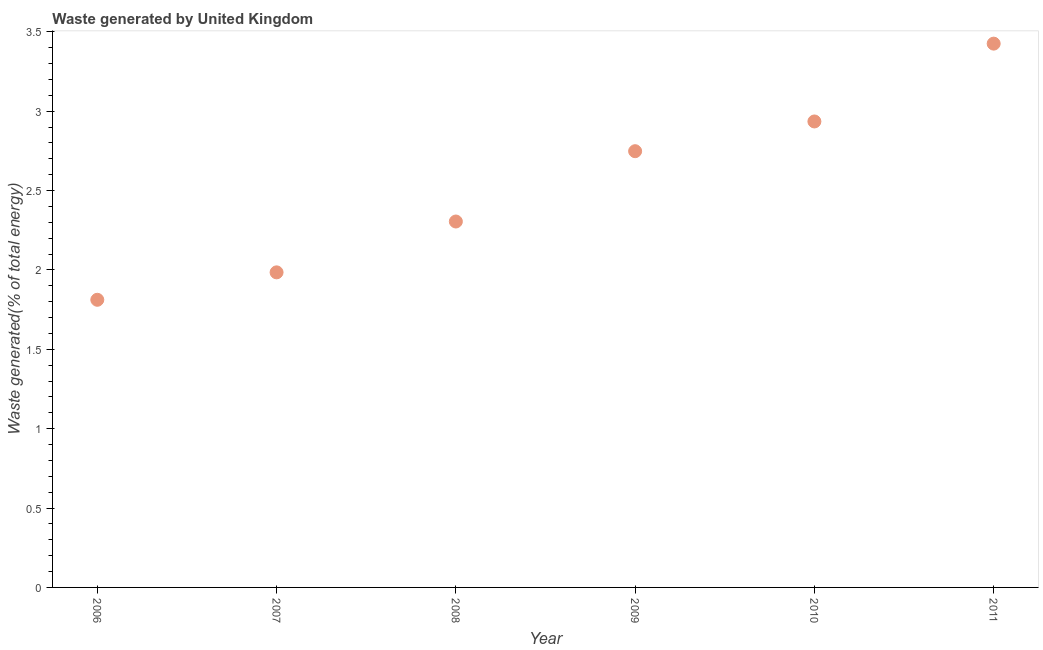What is the amount of waste generated in 2009?
Provide a short and direct response. 2.75. Across all years, what is the maximum amount of waste generated?
Offer a terse response. 3.43. Across all years, what is the minimum amount of waste generated?
Your answer should be very brief. 1.81. In which year was the amount of waste generated maximum?
Ensure brevity in your answer.  2011. What is the sum of the amount of waste generated?
Your response must be concise. 15.21. What is the difference between the amount of waste generated in 2010 and 2011?
Make the answer very short. -0.49. What is the average amount of waste generated per year?
Provide a succinct answer. 2.53. What is the median amount of waste generated?
Make the answer very short. 2.53. What is the ratio of the amount of waste generated in 2007 to that in 2008?
Make the answer very short. 0.86. What is the difference between the highest and the second highest amount of waste generated?
Provide a succinct answer. 0.49. Is the sum of the amount of waste generated in 2007 and 2011 greater than the maximum amount of waste generated across all years?
Provide a succinct answer. Yes. What is the difference between the highest and the lowest amount of waste generated?
Provide a succinct answer. 1.61. Does the amount of waste generated monotonically increase over the years?
Make the answer very short. Yes. How many dotlines are there?
Your response must be concise. 1. Are the values on the major ticks of Y-axis written in scientific E-notation?
Offer a terse response. No. Does the graph contain any zero values?
Your answer should be compact. No. Does the graph contain grids?
Provide a short and direct response. No. What is the title of the graph?
Make the answer very short. Waste generated by United Kingdom. What is the label or title of the X-axis?
Provide a succinct answer. Year. What is the label or title of the Y-axis?
Offer a very short reply. Waste generated(% of total energy). What is the Waste generated(% of total energy) in 2006?
Provide a short and direct response. 1.81. What is the Waste generated(% of total energy) in 2007?
Provide a succinct answer. 1.98. What is the Waste generated(% of total energy) in 2008?
Give a very brief answer. 2.3. What is the Waste generated(% of total energy) in 2009?
Give a very brief answer. 2.75. What is the Waste generated(% of total energy) in 2010?
Your response must be concise. 2.94. What is the Waste generated(% of total energy) in 2011?
Keep it short and to the point. 3.43. What is the difference between the Waste generated(% of total energy) in 2006 and 2007?
Your answer should be compact. -0.17. What is the difference between the Waste generated(% of total energy) in 2006 and 2008?
Your response must be concise. -0.49. What is the difference between the Waste generated(% of total energy) in 2006 and 2009?
Ensure brevity in your answer.  -0.94. What is the difference between the Waste generated(% of total energy) in 2006 and 2010?
Give a very brief answer. -1.12. What is the difference between the Waste generated(% of total energy) in 2006 and 2011?
Make the answer very short. -1.61. What is the difference between the Waste generated(% of total energy) in 2007 and 2008?
Offer a very short reply. -0.32. What is the difference between the Waste generated(% of total energy) in 2007 and 2009?
Your answer should be very brief. -0.76. What is the difference between the Waste generated(% of total energy) in 2007 and 2010?
Your answer should be compact. -0.95. What is the difference between the Waste generated(% of total energy) in 2007 and 2011?
Keep it short and to the point. -1.44. What is the difference between the Waste generated(% of total energy) in 2008 and 2009?
Keep it short and to the point. -0.44. What is the difference between the Waste generated(% of total energy) in 2008 and 2010?
Your answer should be very brief. -0.63. What is the difference between the Waste generated(% of total energy) in 2008 and 2011?
Your response must be concise. -1.12. What is the difference between the Waste generated(% of total energy) in 2009 and 2010?
Make the answer very short. -0.19. What is the difference between the Waste generated(% of total energy) in 2009 and 2011?
Offer a terse response. -0.68. What is the difference between the Waste generated(% of total energy) in 2010 and 2011?
Keep it short and to the point. -0.49. What is the ratio of the Waste generated(% of total energy) in 2006 to that in 2007?
Make the answer very short. 0.91. What is the ratio of the Waste generated(% of total energy) in 2006 to that in 2008?
Ensure brevity in your answer.  0.79. What is the ratio of the Waste generated(% of total energy) in 2006 to that in 2009?
Keep it short and to the point. 0.66. What is the ratio of the Waste generated(% of total energy) in 2006 to that in 2010?
Keep it short and to the point. 0.62. What is the ratio of the Waste generated(% of total energy) in 2006 to that in 2011?
Provide a short and direct response. 0.53. What is the ratio of the Waste generated(% of total energy) in 2007 to that in 2008?
Provide a succinct answer. 0.86. What is the ratio of the Waste generated(% of total energy) in 2007 to that in 2009?
Offer a very short reply. 0.72. What is the ratio of the Waste generated(% of total energy) in 2007 to that in 2010?
Provide a short and direct response. 0.68. What is the ratio of the Waste generated(% of total energy) in 2007 to that in 2011?
Provide a succinct answer. 0.58. What is the ratio of the Waste generated(% of total energy) in 2008 to that in 2009?
Keep it short and to the point. 0.84. What is the ratio of the Waste generated(% of total energy) in 2008 to that in 2010?
Ensure brevity in your answer.  0.79. What is the ratio of the Waste generated(% of total energy) in 2008 to that in 2011?
Your answer should be very brief. 0.67. What is the ratio of the Waste generated(% of total energy) in 2009 to that in 2010?
Give a very brief answer. 0.94. What is the ratio of the Waste generated(% of total energy) in 2009 to that in 2011?
Your answer should be compact. 0.8. What is the ratio of the Waste generated(% of total energy) in 2010 to that in 2011?
Provide a succinct answer. 0.86. 